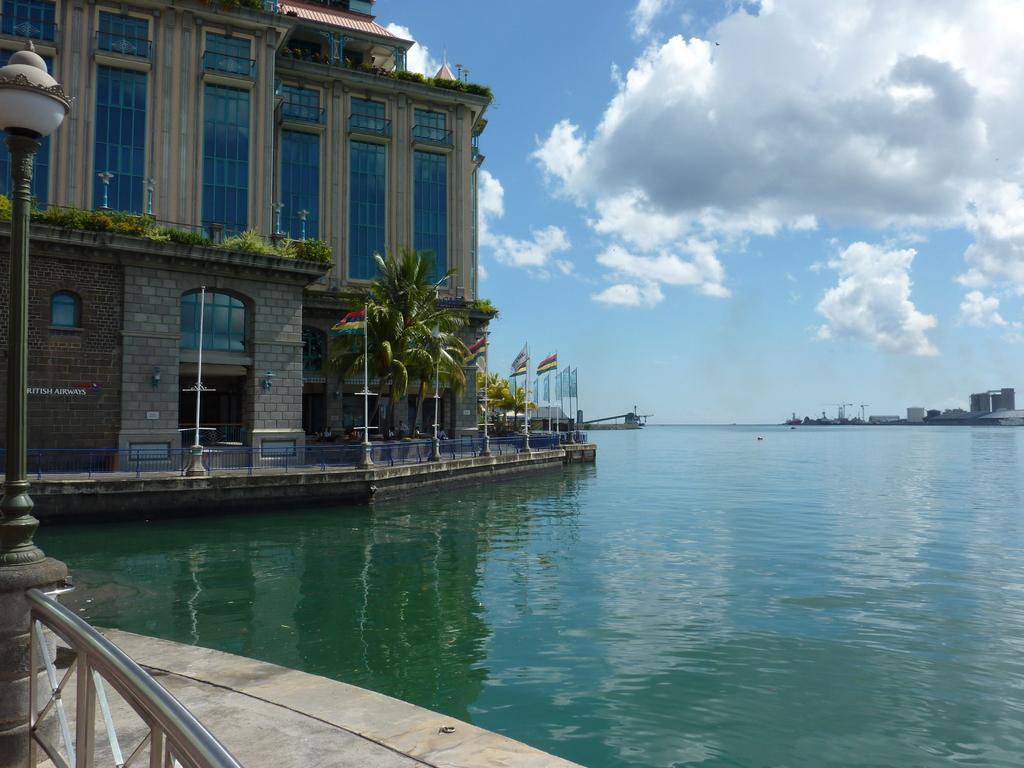How would you summarize this image in a sentence or two? In this image, there are a few buildings, poles, trees, plants, people. We can also see some text on the wall. We can see the fence in the bottom left corner. We can see some water and the sky with clouds. 